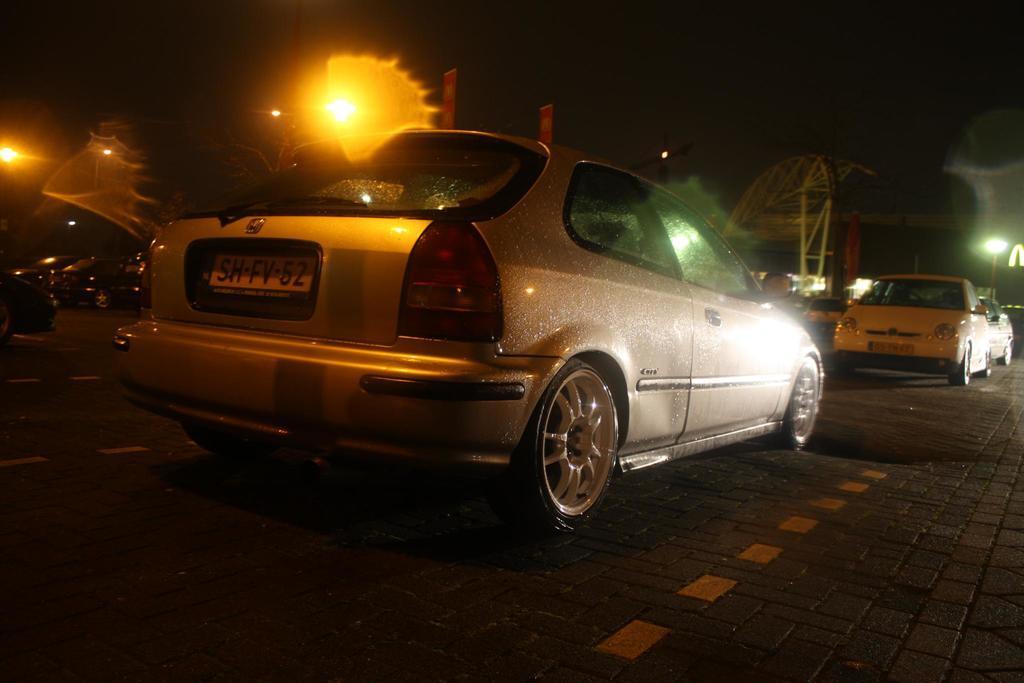How would you summarize this image in a sentence or two? In this image, I can see the cars on the road, lights, tower crane and an object. There is a dark background. 